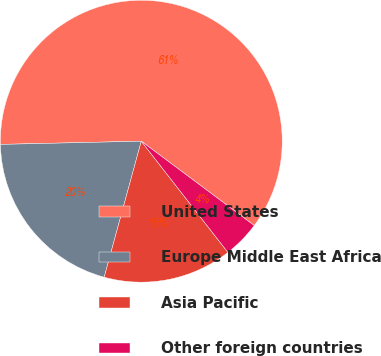<chart> <loc_0><loc_0><loc_500><loc_500><pie_chart><fcel>United States<fcel>Europe Middle East Africa<fcel>Asia Pacific<fcel>Other foreign countries<nl><fcel>60.56%<fcel>20.4%<fcel>14.77%<fcel>4.26%<nl></chart> 